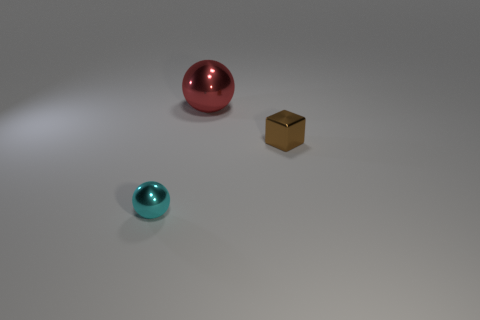Add 3 metal things. How many objects exist? 6 Subtract all spheres. How many objects are left? 1 Subtract all cyan balls. Subtract all blue blocks. How many balls are left? 1 Subtract all gray cylinders. How many red spheres are left? 1 Subtract all cyan shiny spheres. Subtract all cyan metallic balls. How many objects are left? 1 Add 1 big shiny objects. How many big shiny objects are left? 2 Add 2 cyan cubes. How many cyan cubes exist? 2 Subtract 1 brown cubes. How many objects are left? 2 